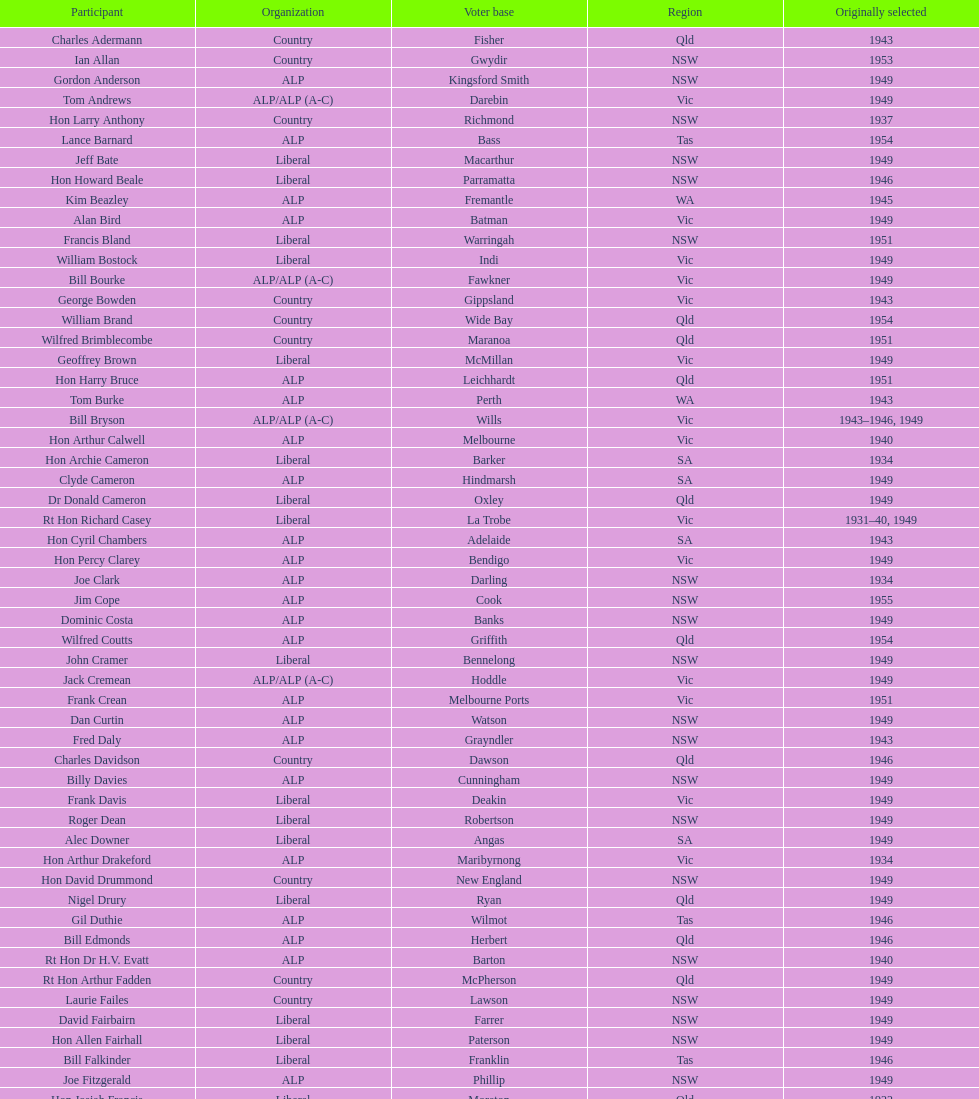What is the number of alp party members elected? 57. 